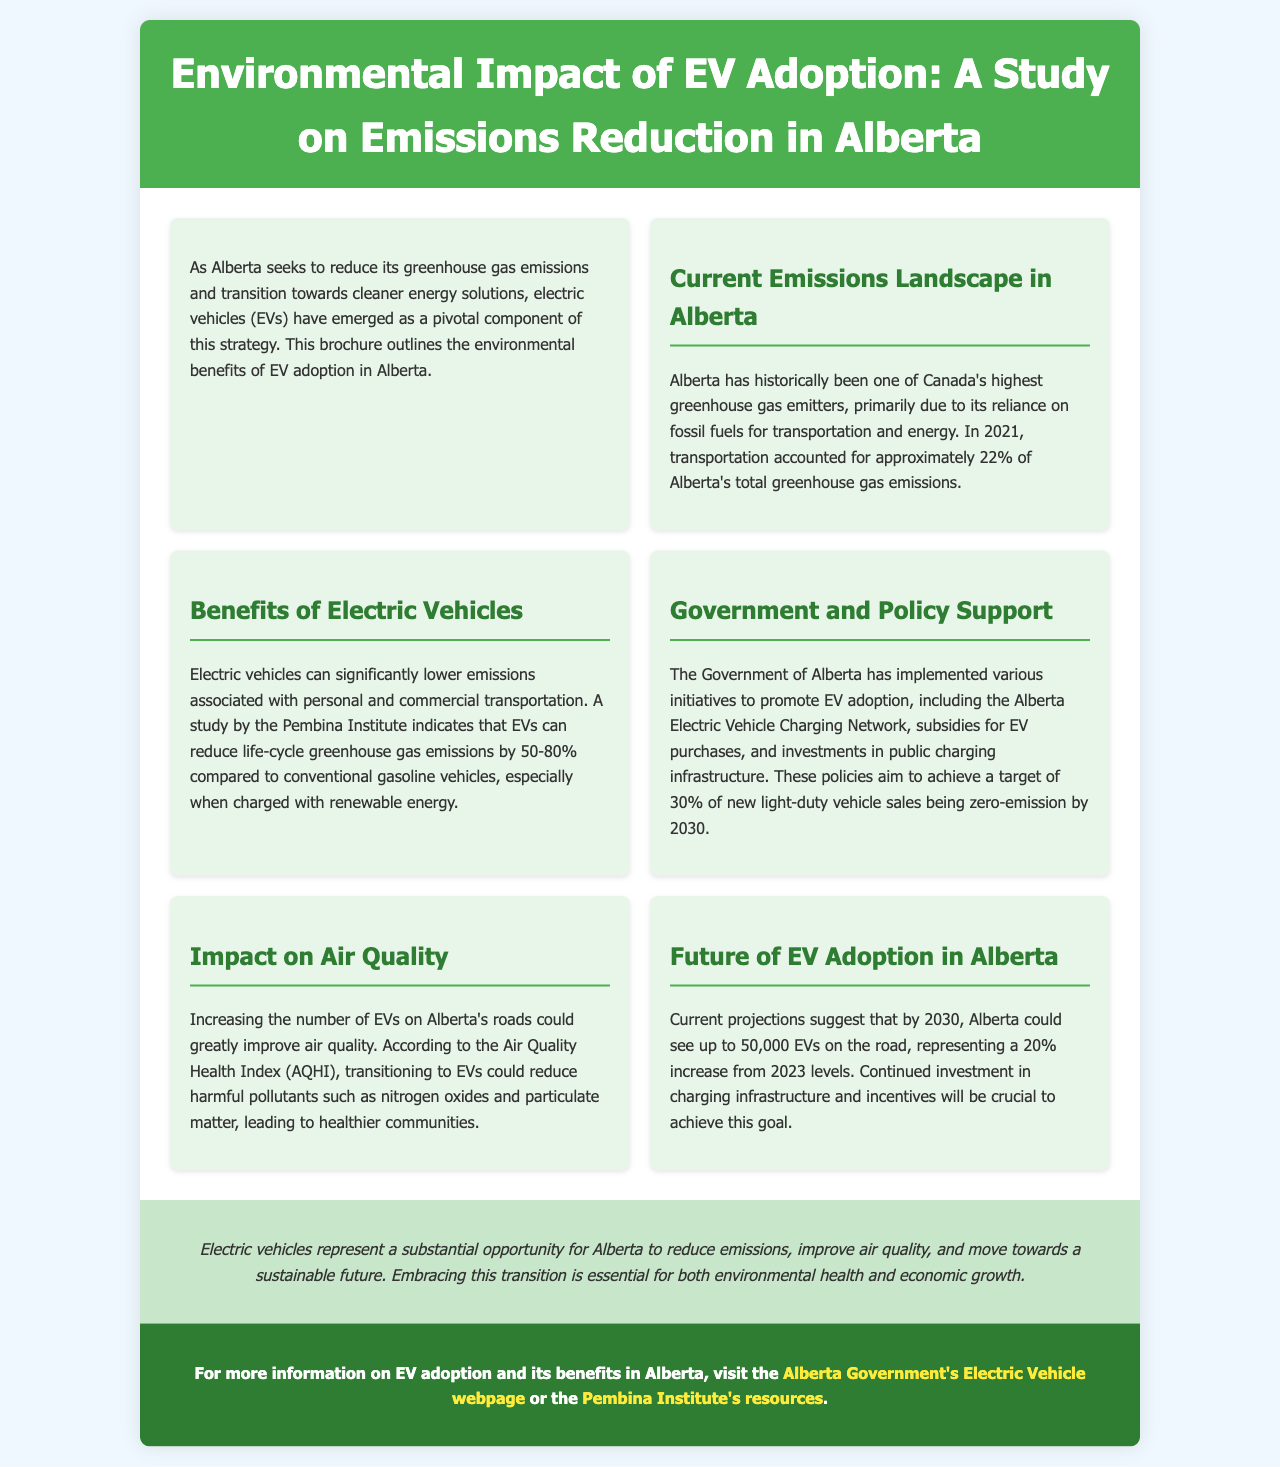What percentage of Alberta's greenhouse gas emissions is attributed to transportation? The document states that transportation accounted for approximately 22% of Alberta's total greenhouse gas emissions in 2021.
Answer: 22% What range of life-cycle greenhouse gas emissions reduction can EVs achieve compared to gasoline vehicles? According to the Pembina Institute study mentioned, EVs can reduce life-cycle greenhouse gas emissions by 50-80%.
Answer: 50-80% What is the target percentage of new light-duty vehicle sales that are expected to be zero-emission by 2030 in Alberta? The brochure specifies that the target is 30% of new light-duty vehicle sales being zero-emission by 2030.
Answer: 30% What health improvements are expected with increased EV adoption in Alberta? The document mentions that transitioning to EVs could reduce harmful pollutants, leading to healthier communities.
Answer: Healthier communities What is the expected number of EVs on Alberta's roads by 2030 according to current projections? The projections suggest that by 2030, Alberta could see up to 50,000 EVs on the road.
Answer: 50,000 What initiative is highlighted as part of the Government of Alberta's support for EV adoption? The Alberta Electric Vehicle Charging Network is mentioned as one of the initiatives to promote EV adoption.
Answer: Alberta Electric Vehicle Charging Network What pollutants are expected to be reduced with the increase in EV usage mentioned in the document? The document specifies harmful pollutants such as nitrogen oxides and particulate matter as expected to be reduced.
Answer: Nitrogen oxides and particulate matter What is the overall conclusion about EVs in Alberta mentioned in the brochure? The conclusion emphasizes that electric vehicles represent a substantial opportunity for Alberta to reduce emissions.
Answer: Reduce emissions 